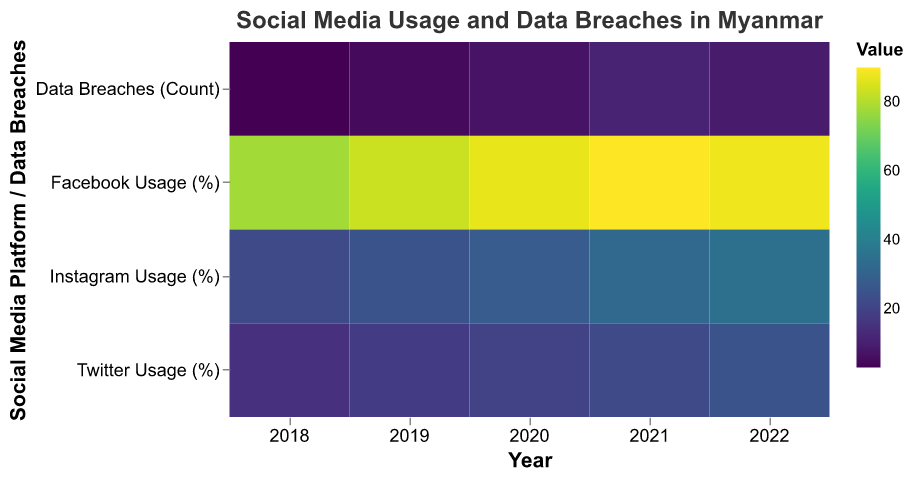What's the title of the Heatmap? The title is displayed at the top of the figure, "Social Media Usage and Data Breaches in Myanmar".
Answer: Social Media Usage and Data Breaches in Myanmar Which year had the highest Facebook usage? Identify the year with the darkest color corresponding to Facebook Usage (%) on the heatmap. In 2021, Facebook Usage reached 90%, the darkest value for that platform.
Answer: 2021 What social media platform had the lowest usage in 2020? Find 2020 and compare the color shades for Facebook, Twitter, and Instagram usage. Twitter has the lightest color, indicating the lowest usage (20%).
Answer: Twitter How many data breaches were reported in 2019 as shown by the heatmap? Locate the year 2019 and observe the color corresponding to Data Breaches (Count). The shade translates to a count of 5.
Answer: 5 By how much did Twitter usage increase from 2018 to 2022? Look at the color change from 2018 to 2022 for Twitter Usage (%), with values increasing from 15% to 25%. Subtract 15 from 25.
Answer: 10% Which year experienced the highest number of data breaches? Examine the year with the darkest shade for the Data Breaches (Count) row. In 2021, the count is highest with 11 breaches.
Answer: 2021 Did Instagram usage increase every year? Track Instagram Usage (%) from 2018 to 2022. The values are 22%, 25%, 28%, 32%, and 35%, showing a consistent increase annually.
Answer: Yes What is the average Facebook usage over the 5 years? Add Facebook Usage (%) values from each year (78 + 83 + 87 + 90 + 88) and divide by 5 to find the average. The sum is 426, and the average is 426/5.
Answer: 85.2% How does the change in data breaches from 2020 to 2021 compare to the change from 2021 to 2022? Calculate the difference in breaches from 2020 (7) to 2021 (11), which is 4. Then calculate the difference from 2021 (11) to 2022 (9), which is -2.
Answer: Increased by 4, decreased by 2 Which platform had the highest usage increase from 2020 to 2022? Compare the increases for Facebook, Twitter, and Instagram from 2020 to 2022. Twitter increased by 5% (20 to 25), and Instagram increased by 7% (28 to 35).
Answer: Instagram 